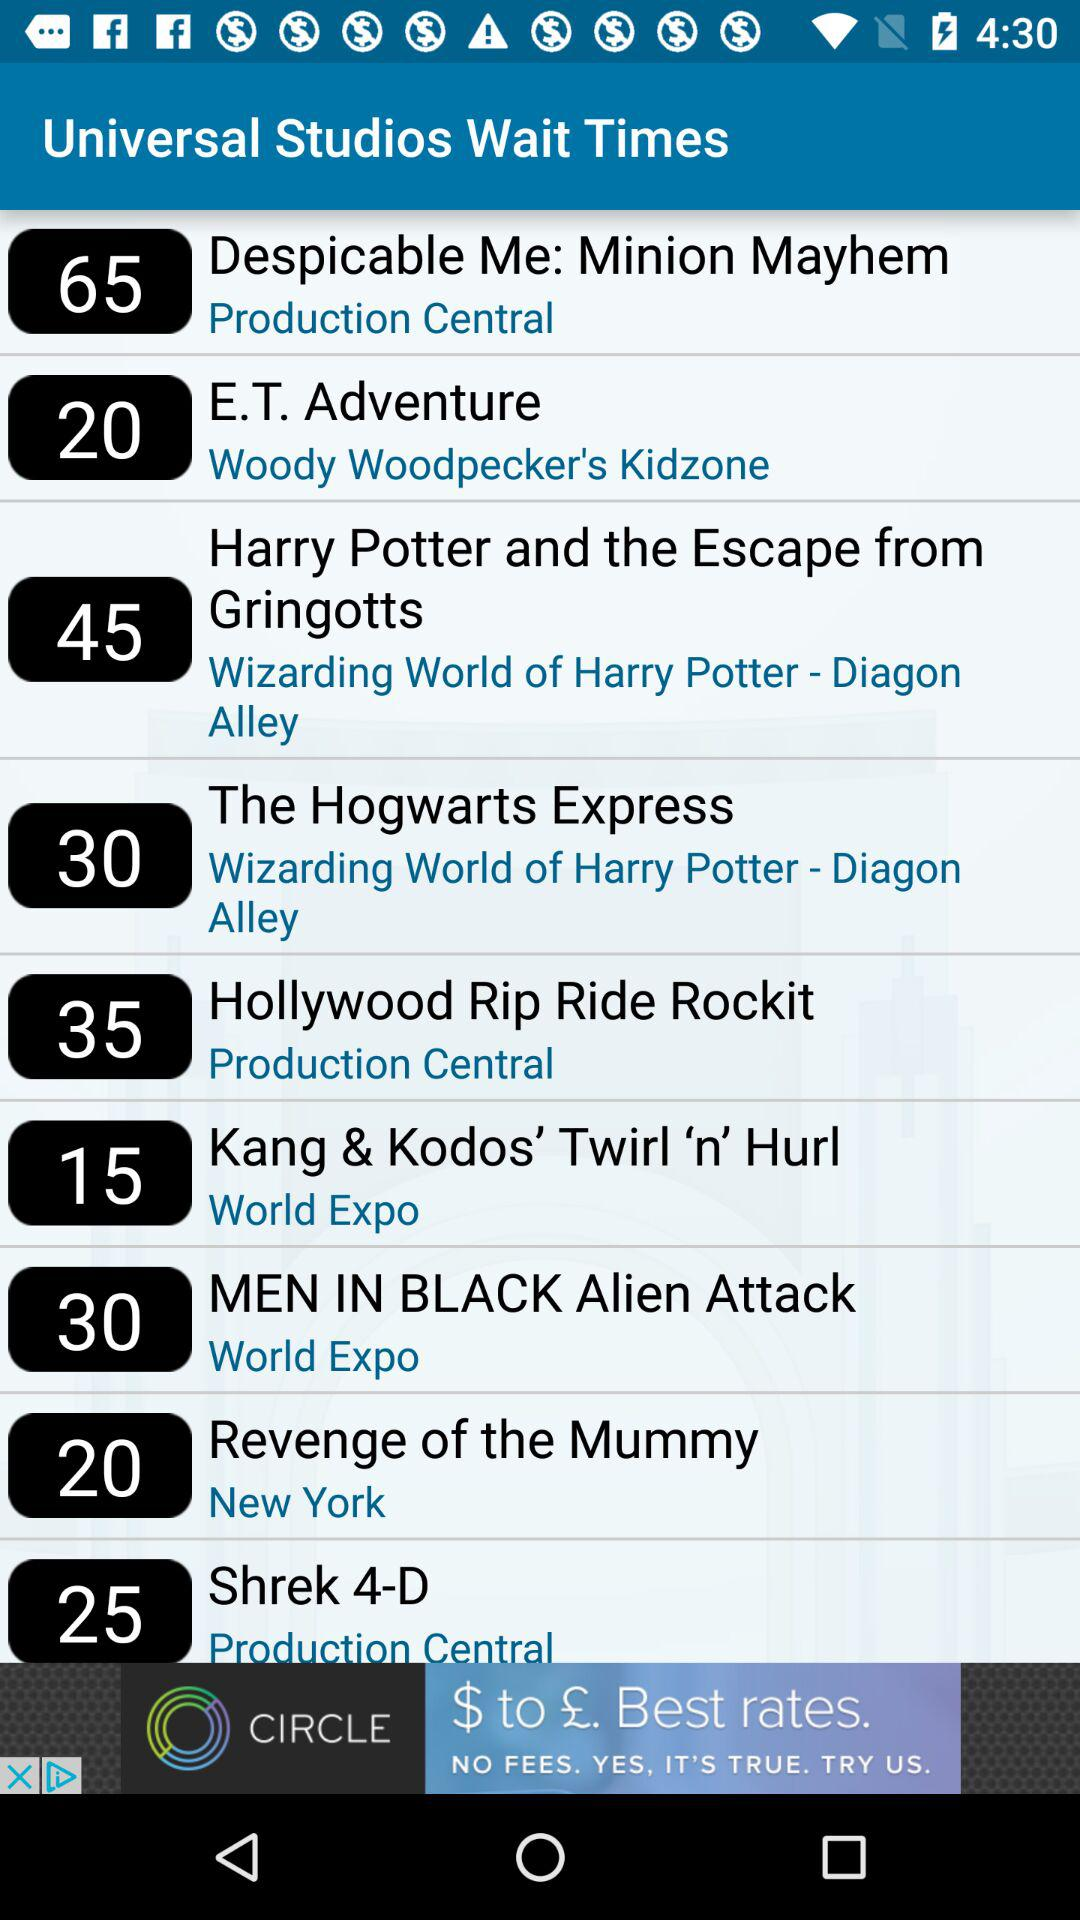What is the wait time for E.T. adventure? The wait time for "E.T. Adventure" is 20. 